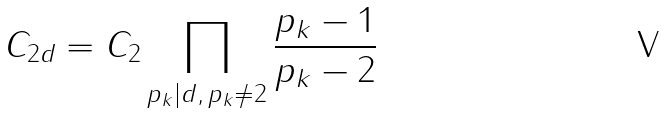Convert formula to latex. <formula><loc_0><loc_0><loc_500><loc_500>C _ { 2 d } = C _ { 2 } \prod _ { p _ { k } | d , \, p _ { k } \ne 2 } \frac { p _ { k } - 1 } { p _ { k } - 2 }</formula> 